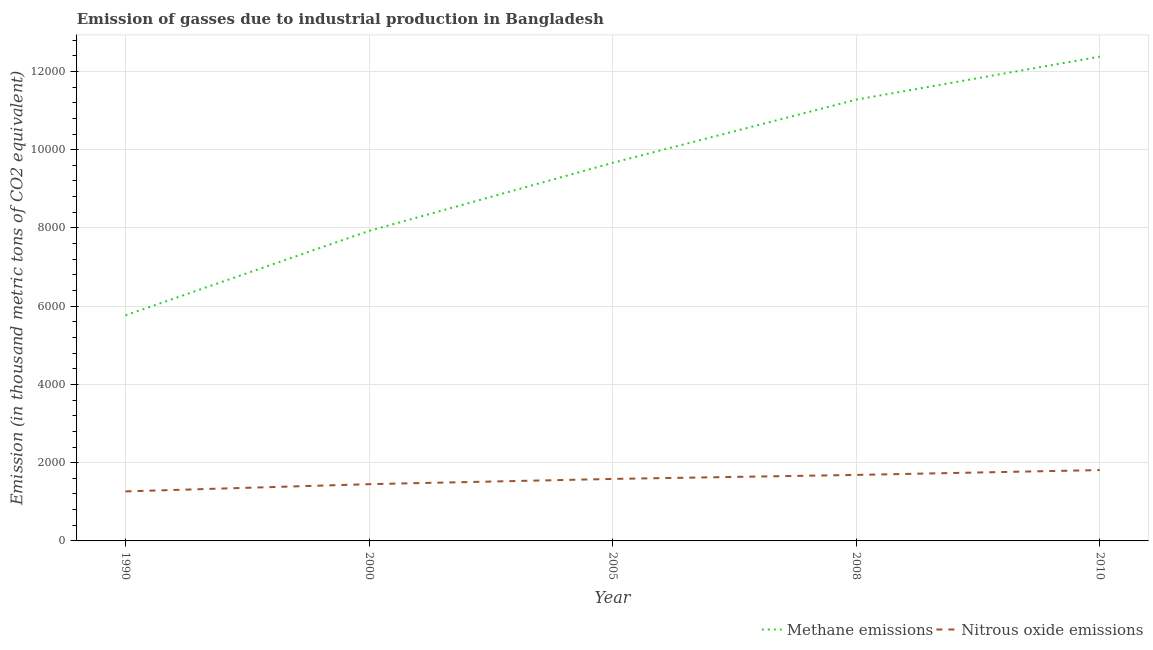Is the number of lines equal to the number of legend labels?
Provide a succinct answer. Yes. What is the amount of nitrous oxide emissions in 2005?
Ensure brevity in your answer.  1584.6. Across all years, what is the maximum amount of nitrous oxide emissions?
Your answer should be compact. 1810.8. Across all years, what is the minimum amount of nitrous oxide emissions?
Offer a very short reply. 1265.7. In which year was the amount of nitrous oxide emissions minimum?
Keep it short and to the point. 1990. What is the total amount of nitrous oxide emissions in the graph?
Your response must be concise. 7798.3. What is the difference between the amount of methane emissions in 2005 and that in 2008?
Provide a succinct answer. -1615.6. What is the difference between the amount of nitrous oxide emissions in 2008 and the amount of methane emissions in 2005?
Your response must be concise. -7976.7. What is the average amount of methane emissions per year?
Your answer should be compact. 9402.26. In the year 2005, what is the difference between the amount of methane emissions and amount of nitrous oxide emissions?
Make the answer very short. 8079. In how many years, is the amount of nitrous oxide emissions greater than 10800 thousand metric tons?
Give a very brief answer. 0. What is the ratio of the amount of nitrous oxide emissions in 2008 to that in 2010?
Make the answer very short. 0.93. Is the amount of nitrous oxide emissions in 2000 less than that in 2008?
Make the answer very short. Yes. What is the difference between the highest and the second highest amount of nitrous oxide emissions?
Your response must be concise. 123.9. What is the difference between the highest and the lowest amount of methane emissions?
Your answer should be very brief. 6612.5. How many lines are there?
Provide a succinct answer. 2. How many years are there in the graph?
Your answer should be compact. 5. What is the difference between two consecutive major ticks on the Y-axis?
Keep it short and to the point. 2000. Are the values on the major ticks of Y-axis written in scientific E-notation?
Provide a short and direct response. No. Where does the legend appear in the graph?
Your response must be concise. Bottom right. How many legend labels are there?
Provide a short and direct response. 2. What is the title of the graph?
Provide a short and direct response. Emission of gasses due to industrial production in Bangladesh. Does "Nonresident" appear as one of the legend labels in the graph?
Your answer should be compact. No. What is the label or title of the X-axis?
Offer a very short reply. Year. What is the label or title of the Y-axis?
Provide a succinct answer. Emission (in thousand metric tons of CO2 equivalent). What is the Emission (in thousand metric tons of CO2 equivalent) in Methane emissions in 1990?
Offer a terse response. 5766.3. What is the Emission (in thousand metric tons of CO2 equivalent) of Nitrous oxide emissions in 1990?
Ensure brevity in your answer.  1265.7. What is the Emission (in thousand metric tons of CO2 equivalent) in Methane emissions in 2000?
Provide a succinct answer. 7923.4. What is the Emission (in thousand metric tons of CO2 equivalent) in Nitrous oxide emissions in 2000?
Your answer should be very brief. 1450.3. What is the Emission (in thousand metric tons of CO2 equivalent) of Methane emissions in 2005?
Keep it short and to the point. 9663.6. What is the Emission (in thousand metric tons of CO2 equivalent) of Nitrous oxide emissions in 2005?
Provide a succinct answer. 1584.6. What is the Emission (in thousand metric tons of CO2 equivalent) of Methane emissions in 2008?
Offer a terse response. 1.13e+04. What is the Emission (in thousand metric tons of CO2 equivalent) of Nitrous oxide emissions in 2008?
Provide a short and direct response. 1686.9. What is the Emission (in thousand metric tons of CO2 equivalent) in Methane emissions in 2010?
Your answer should be very brief. 1.24e+04. What is the Emission (in thousand metric tons of CO2 equivalent) of Nitrous oxide emissions in 2010?
Provide a short and direct response. 1810.8. Across all years, what is the maximum Emission (in thousand metric tons of CO2 equivalent) of Methane emissions?
Your response must be concise. 1.24e+04. Across all years, what is the maximum Emission (in thousand metric tons of CO2 equivalent) of Nitrous oxide emissions?
Keep it short and to the point. 1810.8. Across all years, what is the minimum Emission (in thousand metric tons of CO2 equivalent) in Methane emissions?
Offer a terse response. 5766.3. Across all years, what is the minimum Emission (in thousand metric tons of CO2 equivalent) of Nitrous oxide emissions?
Your response must be concise. 1265.7. What is the total Emission (in thousand metric tons of CO2 equivalent) in Methane emissions in the graph?
Provide a short and direct response. 4.70e+04. What is the total Emission (in thousand metric tons of CO2 equivalent) of Nitrous oxide emissions in the graph?
Give a very brief answer. 7798.3. What is the difference between the Emission (in thousand metric tons of CO2 equivalent) in Methane emissions in 1990 and that in 2000?
Keep it short and to the point. -2157.1. What is the difference between the Emission (in thousand metric tons of CO2 equivalent) in Nitrous oxide emissions in 1990 and that in 2000?
Offer a terse response. -184.6. What is the difference between the Emission (in thousand metric tons of CO2 equivalent) in Methane emissions in 1990 and that in 2005?
Your answer should be compact. -3897.3. What is the difference between the Emission (in thousand metric tons of CO2 equivalent) of Nitrous oxide emissions in 1990 and that in 2005?
Keep it short and to the point. -318.9. What is the difference between the Emission (in thousand metric tons of CO2 equivalent) in Methane emissions in 1990 and that in 2008?
Give a very brief answer. -5512.9. What is the difference between the Emission (in thousand metric tons of CO2 equivalent) of Nitrous oxide emissions in 1990 and that in 2008?
Ensure brevity in your answer.  -421.2. What is the difference between the Emission (in thousand metric tons of CO2 equivalent) of Methane emissions in 1990 and that in 2010?
Your answer should be compact. -6612.5. What is the difference between the Emission (in thousand metric tons of CO2 equivalent) in Nitrous oxide emissions in 1990 and that in 2010?
Make the answer very short. -545.1. What is the difference between the Emission (in thousand metric tons of CO2 equivalent) in Methane emissions in 2000 and that in 2005?
Your response must be concise. -1740.2. What is the difference between the Emission (in thousand metric tons of CO2 equivalent) in Nitrous oxide emissions in 2000 and that in 2005?
Offer a terse response. -134.3. What is the difference between the Emission (in thousand metric tons of CO2 equivalent) in Methane emissions in 2000 and that in 2008?
Offer a terse response. -3355.8. What is the difference between the Emission (in thousand metric tons of CO2 equivalent) in Nitrous oxide emissions in 2000 and that in 2008?
Ensure brevity in your answer.  -236.6. What is the difference between the Emission (in thousand metric tons of CO2 equivalent) in Methane emissions in 2000 and that in 2010?
Offer a very short reply. -4455.4. What is the difference between the Emission (in thousand metric tons of CO2 equivalent) in Nitrous oxide emissions in 2000 and that in 2010?
Offer a terse response. -360.5. What is the difference between the Emission (in thousand metric tons of CO2 equivalent) in Methane emissions in 2005 and that in 2008?
Your answer should be compact. -1615.6. What is the difference between the Emission (in thousand metric tons of CO2 equivalent) in Nitrous oxide emissions in 2005 and that in 2008?
Make the answer very short. -102.3. What is the difference between the Emission (in thousand metric tons of CO2 equivalent) in Methane emissions in 2005 and that in 2010?
Your response must be concise. -2715.2. What is the difference between the Emission (in thousand metric tons of CO2 equivalent) in Nitrous oxide emissions in 2005 and that in 2010?
Keep it short and to the point. -226.2. What is the difference between the Emission (in thousand metric tons of CO2 equivalent) in Methane emissions in 2008 and that in 2010?
Your response must be concise. -1099.6. What is the difference between the Emission (in thousand metric tons of CO2 equivalent) of Nitrous oxide emissions in 2008 and that in 2010?
Your answer should be very brief. -123.9. What is the difference between the Emission (in thousand metric tons of CO2 equivalent) of Methane emissions in 1990 and the Emission (in thousand metric tons of CO2 equivalent) of Nitrous oxide emissions in 2000?
Your answer should be very brief. 4316. What is the difference between the Emission (in thousand metric tons of CO2 equivalent) of Methane emissions in 1990 and the Emission (in thousand metric tons of CO2 equivalent) of Nitrous oxide emissions in 2005?
Ensure brevity in your answer.  4181.7. What is the difference between the Emission (in thousand metric tons of CO2 equivalent) in Methane emissions in 1990 and the Emission (in thousand metric tons of CO2 equivalent) in Nitrous oxide emissions in 2008?
Ensure brevity in your answer.  4079.4. What is the difference between the Emission (in thousand metric tons of CO2 equivalent) of Methane emissions in 1990 and the Emission (in thousand metric tons of CO2 equivalent) of Nitrous oxide emissions in 2010?
Keep it short and to the point. 3955.5. What is the difference between the Emission (in thousand metric tons of CO2 equivalent) in Methane emissions in 2000 and the Emission (in thousand metric tons of CO2 equivalent) in Nitrous oxide emissions in 2005?
Keep it short and to the point. 6338.8. What is the difference between the Emission (in thousand metric tons of CO2 equivalent) in Methane emissions in 2000 and the Emission (in thousand metric tons of CO2 equivalent) in Nitrous oxide emissions in 2008?
Offer a very short reply. 6236.5. What is the difference between the Emission (in thousand metric tons of CO2 equivalent) of Methane emissions in 2000 and the Emission (in thousand metric tons of CO2 equivalent) of Nitrous oxide emissions in 2010?
Offer a terse response. 6112.6. What is the difference between the Emission (in thousand metric tons of CO2 equivalent) of Methane emissions in 2005 and the Emission (in thousand metric tons of CO2 equivalent) of Nitrous oxide emissions in 2008?
Provide a succinct answer. 7976.7. What is the difference between the Emission (in thousand metric tons of CO2 equivalent) in Methane emissions in 2005 and the Emission (in thousand metric tons of CO2 equivalent) in Nitrous oxide emissions in 2010?
Offer a terse response. 7852.8. What is the difference between the Emission (in thousand metric tons of CO2 equivalent) of Methane emissions in 2008 and the Emission (in thousand metric tons of CO2 equivalent) of Nitrous oxide emissions in 2010?
Offer a terse response. 9468.4. What is the average Emission (in thousand metric tons of CO2 equivalent) of Methane emissions per year?
Provide a short and direct response. 9402.26. What is the average Emission (in thousand metric tons of CO2 equivalent) in Nitrous oxide emissions per year?
Keep it short and to the point. 1559.66. In the year 1990, what is the difference between the Emission (in thousand metric tons of CO2 equivalent) of Methane emissions and Emission (in thousand metric tons of CO2 equivalent) of Nitrous oxide emissions?
Provide a succinct answer. 4500.6. In the year 2000, what is the difference between the Emission (in thousand metric tons of CO2 equivalent) in Methane emissions and Emission (in thousand metric tons of CO2 equivalent) in Nitrous oxide emissions?
Make the answer very short. 6473.1. In the year 2005, what is the difference between the Emission (in thousand metric tons of CO2 equivalent) of Methane emissions and Emission (in thousand metric tons of CO2 equivalent) of Nitrous oxide emissions?
Provide a short and direct response. 8079. In the year 2008, what is the difference between the Emission (in thousand metric tons of CO2 equivalent) in Methane emissions and Emission (in thousand metric tons of CO2 equivalent) in Nitrous oxide emissions?
Your response must be concise. 9592.3. In the year 2010, what is the difference between the Emission (in thousand metric tons of CO2 equivalent) in Methane emissions and Emission (in thousand metric tons of CO2 equivalent) in Nitrous oxide emissions?
Provide a succinct answer. 1.06e+04. What is the ratio of the Emission (in thousand metric tons of CO2 equivalent) in Methane emissions in 1990 to that in 2000?
Ensure brevity in your answer.  0.73. What is the ratio of the Emission (in thousand metric tons of CO2 equivalent) of Nitrous oxide emissions in 1990 to that in 2000?
Provide a succinct answer. 0.87. What is the ratio of the Emission (in thousand metric tons of CO2 equivalent) in Methane emissions in 1990 to that in 2005?
Give a very brief answer. 0.6. What is the ratio of the Emission (in thousand metric tons of CO2 equivalent) of Nitrous oxide emissions in 1990 to that in 2005?
Provide a short and direct response. 0.8. What is the ratio of the Emission (in thousand metric tons of CO2 equivalent) of Methane emissions in 1990 to that in 2008?
Offer a terse response. 0.51. What is the ratio of the Emission (in thousand metric tons of CO2 equivalent) of Nitrous oxide emissions in 1990 to that in 2008?
Your response must be concise. 0.75. What is the ratio of the Emission (in thousand metric tons of CO2 equivalent) of Methane emissions in 1990 to that in 2010?
Give a very brief answer. 0.47. What is the ratio of the Emission (in thousand metric tons of CO2 equivalent) of Nitrous oxide emissions in 1990 to that in 2010?
Provide a short and direct response. 0.7. What is the ratio of the Emission (in thousand metric tons of CO2 equivalent) of Methane emissions in 2000 to that in 2005?
Ensure brevity in your answer.  0.82. What is the ratio of the Emission (in thousand metric tons of CO2 equivalent) in Nitrous oxide emissions in 2000 to that in 2005?
Your response must be concise. 0.92. What is the ratio of the Emission (in thousand metric tons of CO2 equivalent) in Methane emissions in 2000 to that in 2008?
Offer a terse response. 0.7. What is the ratio of the Emission (in thousand metric tons of CO2 equivalent) of Nitrous oxide emissions in 2000 to that in 2008?
Your response must be concise. 0.86. What is the ratio of the Emission (in thousand metric tons of CO2 equivalent) in Methane emissions in 2000 to that in 2010?
Make the answer very short. 0.64. What is the ratio of the Emission (in thousand metric tons of CO2 equivalent) in Nitrous oxide emissions in 2000 to that in 2010?
Make the answer very short. 0.8. What is the ratio of the Emission (in thousand metric tons of CO2 equivalent) in Methane emissions in 2005 to that in 2008?
Your answer should be very brief. 0.86. What is the ratio of the Emission (in thousand metric tons of CO2 equivalent) of Nitrous oxide emissions in 2005 to that in 2008?
Offer a very short reply. 0.94. What is the ratio of the Emission (in thousand metric tons of CO2 equivalent) of Methane emissions in 2005 to that in 2010?
Your answer should be very brief. 0.78. What is the ratio of the Emission (in thousand metric tons of CO2 equivalent) in Nitrous oxide emissions in 2005 to that in 2010?
Your answer should be compact. 0.88. What is the ratio of the Emission (in thousand metric tons of CO2 equivalent) in Methane emissions in 2008 to that in 2010?
Your answer should be compact. 0.91. What is the ratio of the Emission (in thousand metric tons of CO2 equivalent) of Nitrous oxide emissions in 2008 to that in 2010?
Your answer should be compact. 0.93. What is the difference between the highest and the second highest Emission (in thousand metric tons of CO2 equivalent) of Methane emissions?
Keep it short and to the point. 1099.6. What is the difference between the highest and the second highest Emission (in thousand metric tons of CO2 equivalent) of Nitrous oxide emissions?
Offer a very short reply. 123.9. What is the difference between the highest and the lowest Emission (in thousand metric tons of CO2 equivalent) in Methane emissions?
Offer a terse response. 6612.5. What is the difference between the highest and the lowest Emission (in thousand metric tons of CO2 equivalent) in Nitrous oxide emissions?
Your response must be concise. 545.1. 